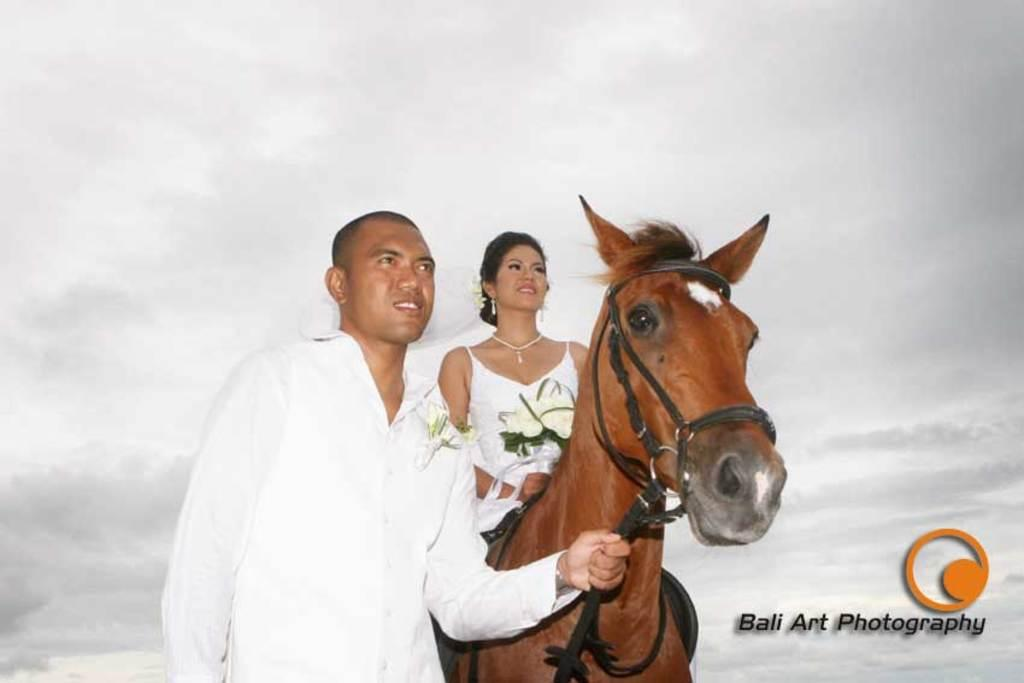What is the man in the image doing? The man is standing and holding a horse in the image. What is the woman in the image doing? The woman is seated on the horse and holding a bouquet. Can you describe the horse in the image? The horse is being held by the man and has a woman seated on it. What is visible in the background of the image? The sky is visible in the background of the image. What is the condition of the sky in the image? The sky is cloudy in the image. What type of soup is being served in the image? There is no soup present in the image; it features a man holding a horse with a woman seated on it. What kind of beast is accompanying the man and woman in the image? There is no beast present in the image; the only animal featured is the horse. 